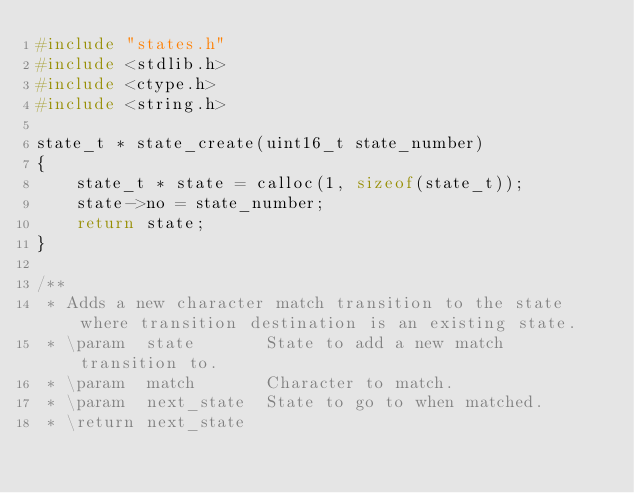Convert code to text. <code><loc_0><loc_0><loc_500><loc_500><_C_>#include "states.h"
#include <stdlib.h>
#include <ctype.h>
#include <string.h>

state_t * state_create(uint16_t state_number)
{
    state_t * state = calloc(1, sizeof(state_t));
    state->no = state_number;
    return state;
}

/**
 * Adds a new character match transition to the state where transition destination is an existing state.
 * \param  state       State to add a new match transition to.
 * \param  match       Character to match.
 * \param  next_state  State to go to when matched.
 * \return next_state</code> 